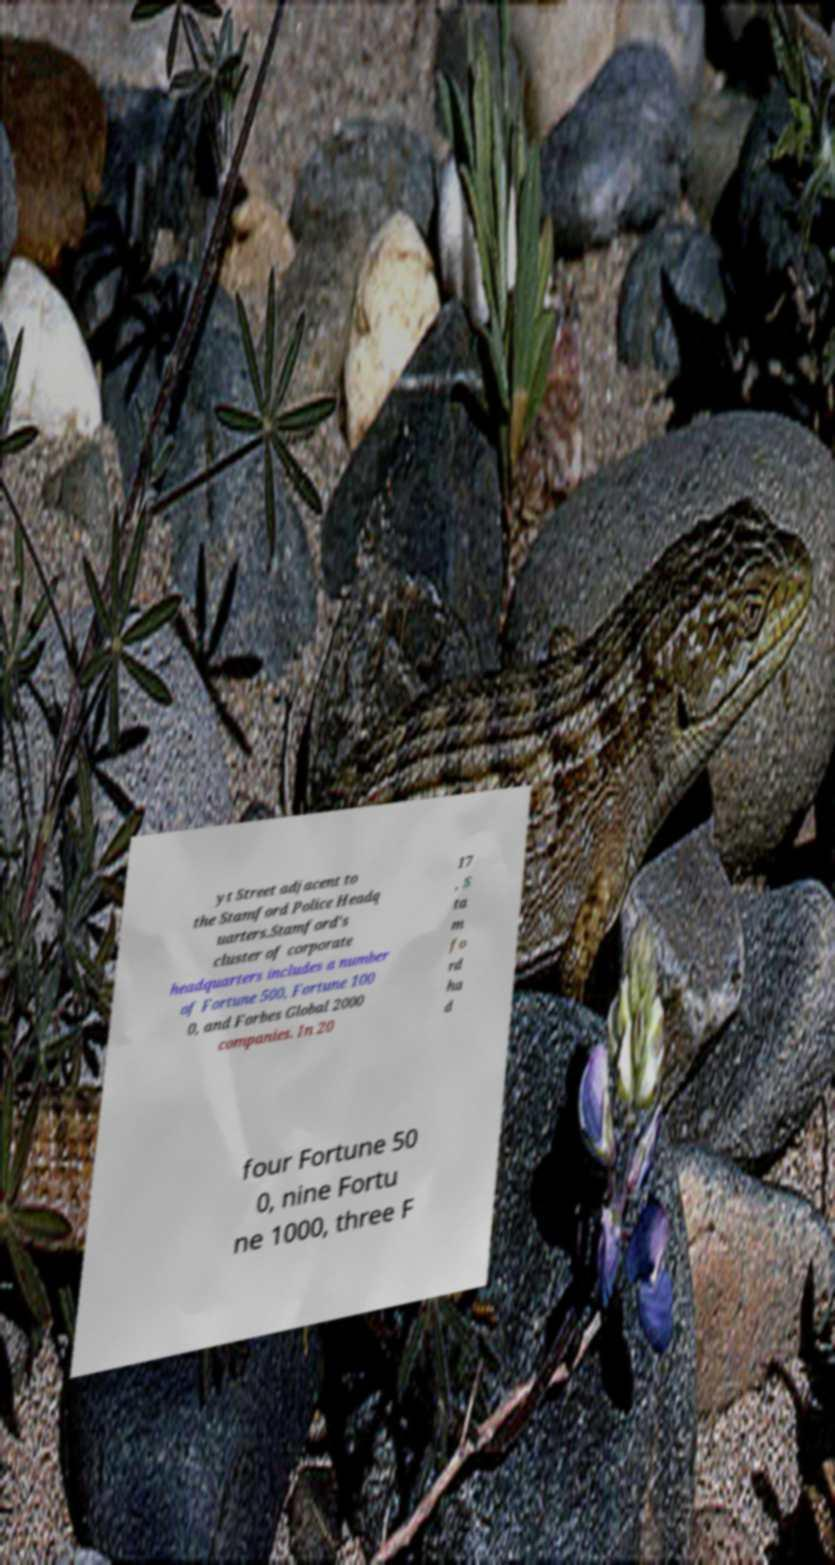Could you extract and type out the text from this image? yt Street adjacent to the Stamford Police Headq uarters.Stamford's cluster of corporate headquarters includes a number of Fortune 500, Fortune 100 0, and Forbes Global 2000 companies. In 20 17 , S ta m fo rd ha d four Fortune 50 0, nine Fortu ne 1000, three F 